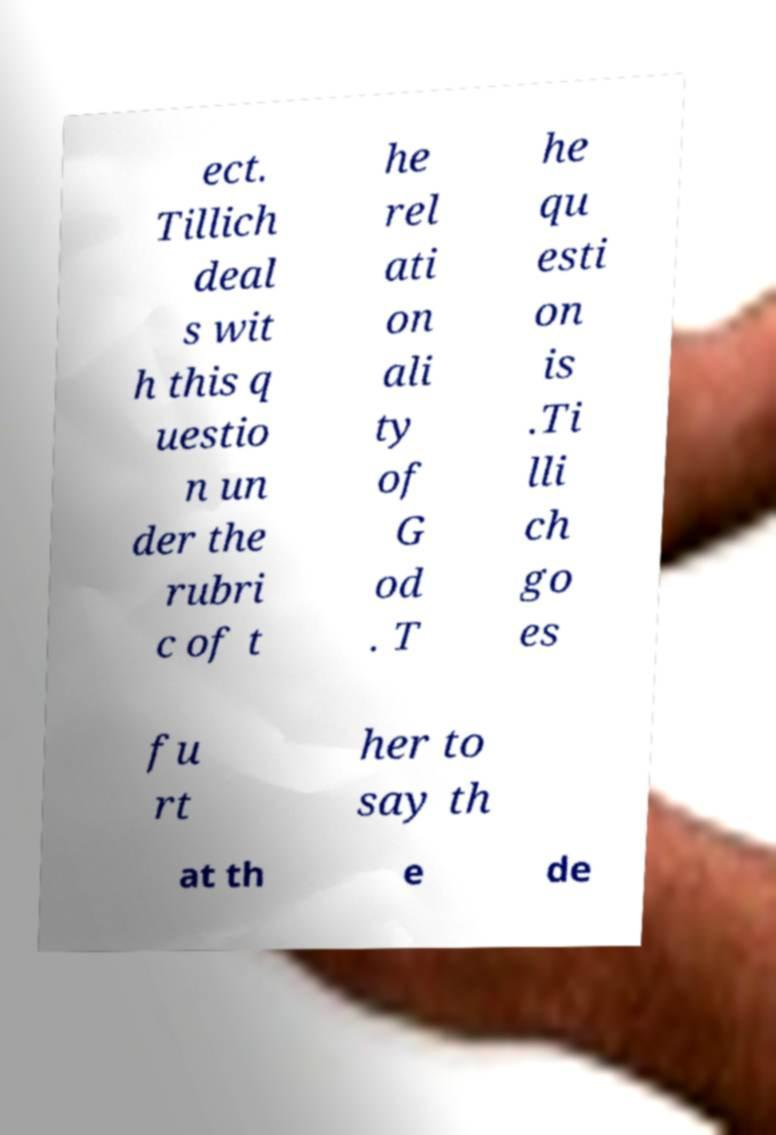Please read and relay the text visible in this image. What does it say? ect. Tillich deal s wit h this q uestio n un der the rubri c of t he rel ati on ali ty of G od . T he qu esti on is .Ti lli ch go es fu rt her to say th at th e de 